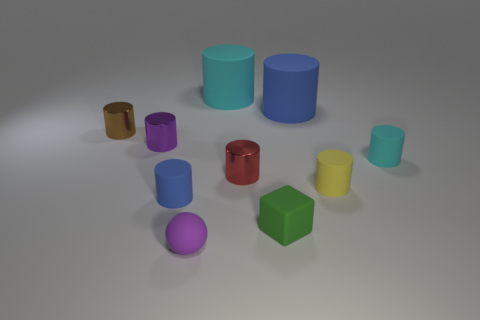Are there fewer purple cylinders in front of the matte block than brown shiny things behind the small purple cylinder?
Ensure brevity in your answer.  Yes. There is a rubber sphere; are there any green things left of it?
Give a very brief answer. No. What number of things are small metallic cylinders in front of the brown metal cylinder or blue rubber cylinders in front of the yellow rubber cylinder?
Your answer should be compact. 3. How many tiny shiny cylinders have the same color as the matte sphere?
Your answer should be compact. 1. What color is the other big object that is the same shape as the big blue matte object?
Offer a terse response. Cyan. What shape is the object that is behind the purple cylinder and left of the big cyan matte thing?
Provide a succinct answer. Cylinder. Are there more blue matte blocks than tiny rubber blocks?
Ensure brevity in your answer.  No. What material is the small red cylinder?
Keep it short and to the point. Metal. There is another cyan rubber object that is the same shape as the tiny cyan rubber object; what size is it?
Ensure brevity in your answer.  Large. Are there any cyan objects that are behind the tiny matte thing that is on the right side of the yellow rubber cylinder?
Provide a succinct answer. Yes. 